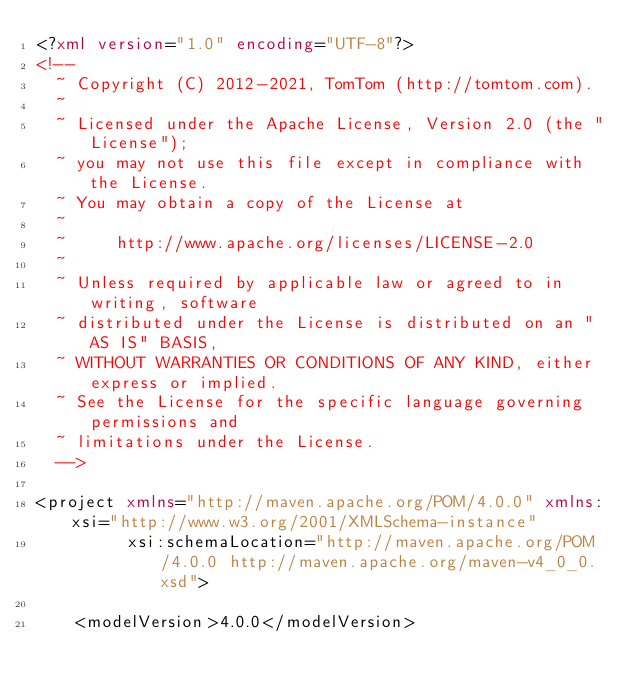Convert code to text. <code><loc_0><loc_0><loc_500><loc_500><_XML_><?xml version="1.0" encoding="UTF-8"?>
<!--
  ~ Copyright (C) 2012-2021, TomTom (http://tomtom.com).
  ~
  ~ Licensed under the Apache License, Version 2.0 (the "License");
  ~ you may not use this file except in compliance with the License.
  ~ You may obtain a copy of the License at
  ~
  ~     http://www.apache.org/licenses/LICENSE-2.0
  ~
  ~ Unless required by applicable law or agreed to in writing, software
  ~ distributed under the License is distributed on an "AS IS" BASIS,
  ~ WITHOUT WARRANTIES OR CONDITIONS OF ANY KIND, either express or implied.
  ~ See the License for the specific language governing permissions and
  ~ limitations under the License.
  -->

<project xmlns="http://maven.apache.org/POM/4.0.0" xmlns:xsi="http://www.w3.org/2001/XMLSchema-instance"
         xsi:schemaLocation="http://maven.apache.org/POM/4.0.0 http://maven.apache.org/maven-v4_0_0.xsd">

    <modelVersion>4.0.0</modelVersion>
</code> 